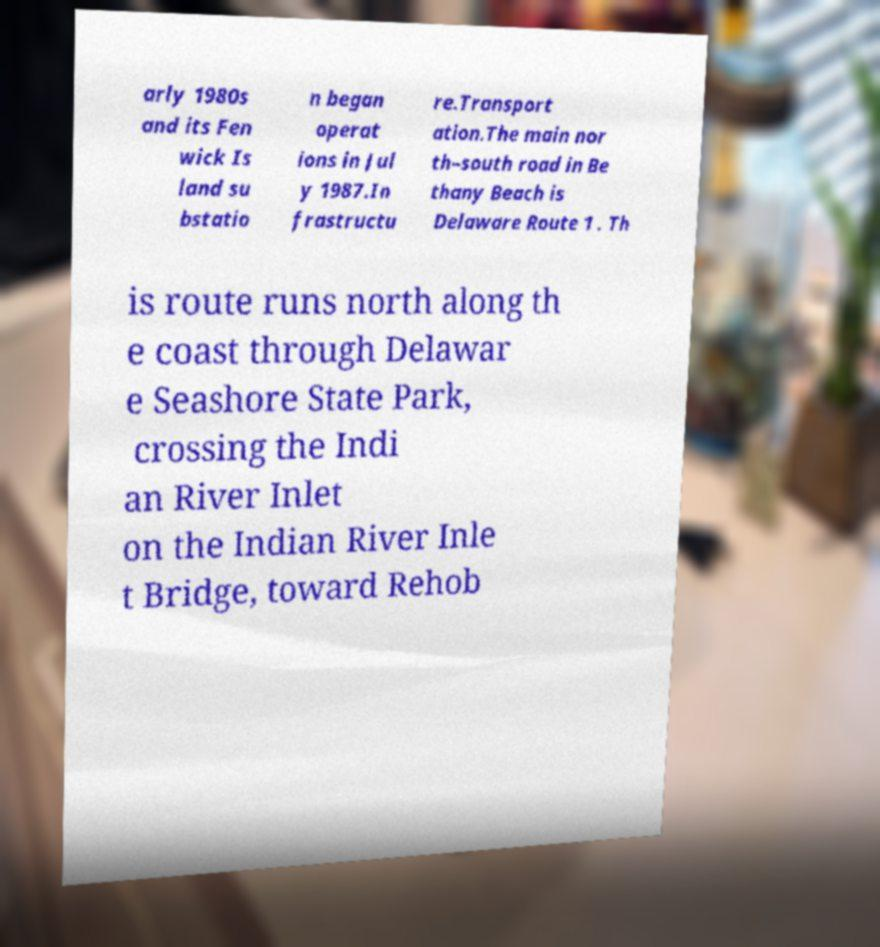Please read and relay the text visible in this image. What does it say? arly 1980s and its Fen wick Is land su bstatio n began operat ions in Jul y 1987.In frastructu re.Transport ation.The main nor th–south road in Be thany Beach is Delaware Route 1 . Th is route runs north along th e coast through Delawar e Seashore State Park, crossing the Indi an River Inlet on the Indian River Inle t Bridge, toward Rehob 